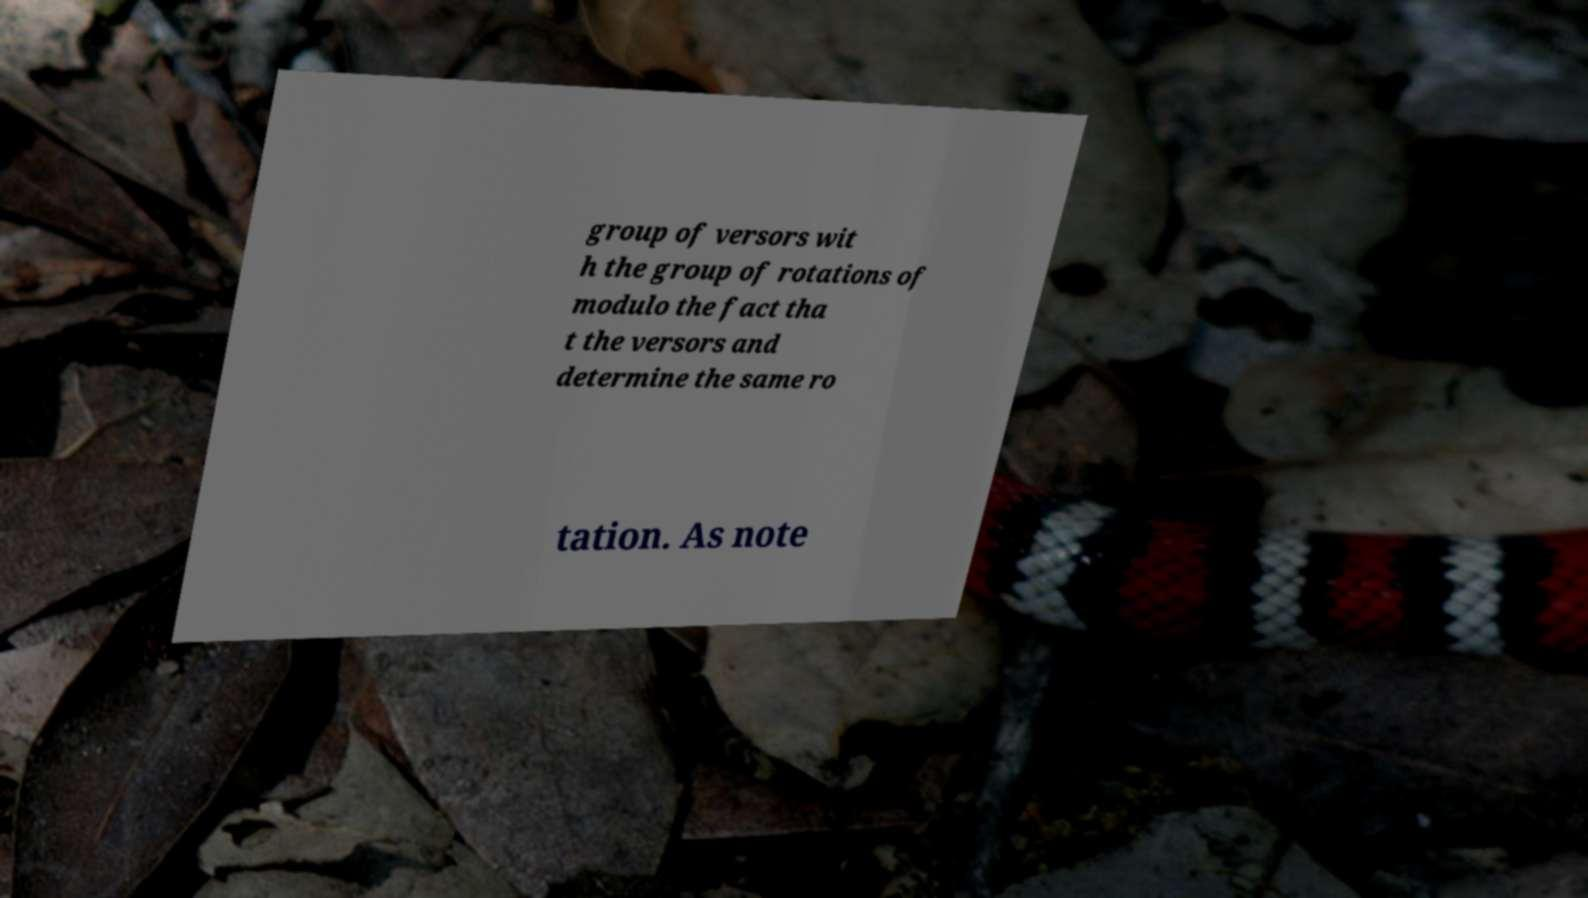Could you extract and type out the text from this image? group of versors wit h the group of rotations of modulo the fact tha t the versors and determine the same ro tation. As note 